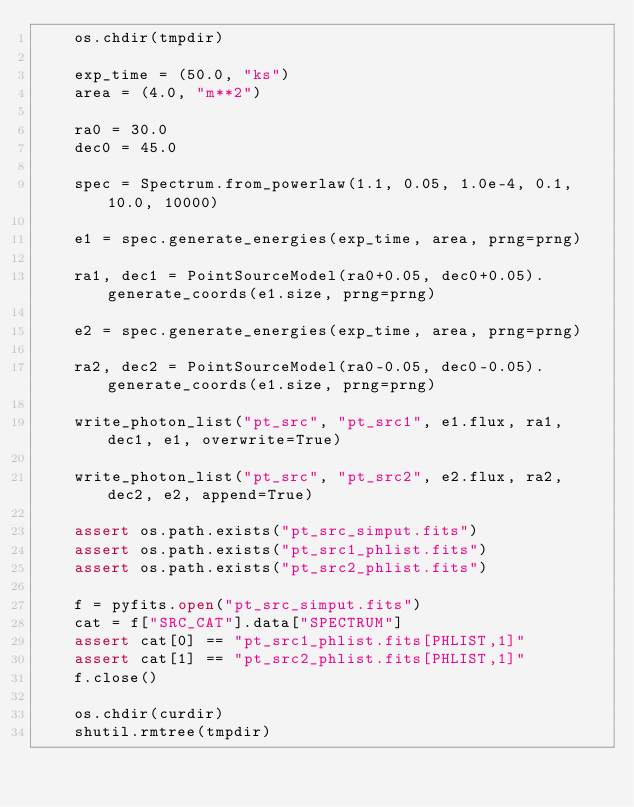<code> <loc_0><loc_0><loc_500><loc_500><_Python_>    os.chdir(tmpdir)

    exp_time = (50.0, "ks")
    area = (4.0, "m**2")

    ra0 = 30.0
    dec0 = 45.0

    spec = Spectrum.from_powerlaw(1.1, 0.05, 1.0e-4, 0.1, 10.0, 10000)

    e1 = spec.generate_energies(exp_time, area, prng=prng)

    ra1, dec1 = PointSourceModel(ra0+0.05, dec0+0.05).generate_coords(e1.size, prng=prng)

    e2 = spec.generate_energies(exp_time, area, prng=prng)

    ra2, dec2 = PointSourceModel(ra0-0.05, dec0-0.05).generate_coords(e1.size, prng=prng)

    write_photon_list("pt_src", "pt_src1", e1.flux, ra1, dec1, e1, overwrite=True)

    write_photon_list("pt_src", "pt_src2", e2.flux, ra2, dec2, e2, append=True)

    assert os.path.exists("pt_src_simput.fits")
    assert os.path.exists("pt_src1_phlist.fits")
    assert os.path.exists("pt_src2_phlist.fits")

    f = pyfits.open("pt_src_simput.fits")
    cat = f["SRC_CAT"].data["SPECTRUM"]
    assert cat[0] == "pt_src1_phlist.fits[PHLIST,1]"
    assert cat[1] == "pt_src2_phlist.fits[PHLIST,1]"
    f.close()

    os.chdir(curdir)
    shutil.rmtree(tmpdir)

</code> 